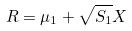<formula> <loc_0><loc_0><loc_500><loc_500>R = \mu _ { 1 } + \sqrt { S _ { 1 } } X</formula> 